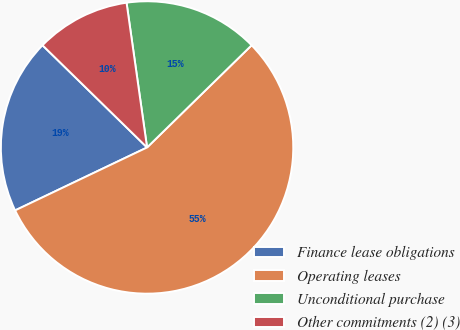<chart> <loc_0><loc_0><loc_500><loc_500><pie_chart><fcel>Finance lease obligations<fcel>Operating leases<fcel>Unconditional purchase<fcel>Other commitments (2) (3)<nl><fcel>19.4%<fcel>55.23%<fcel>14.92%<fcel>10.44%<nl></chart> 